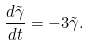Convert formula to latex. <formula><loc_0><loc_0><loc_500><loc_500>\frac { d \tilde { \gamma } } { d t } = - 3 \tilde { \gamma } .</formula> 